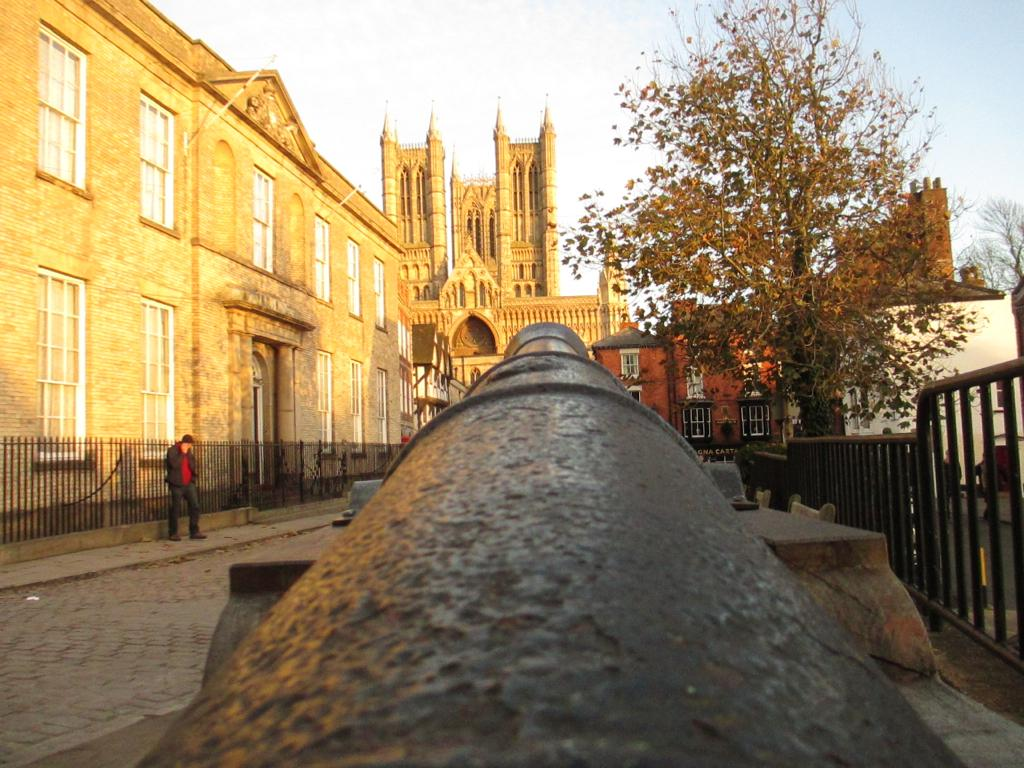What is the main object in the image? There is an object in the image, but the specific object is not mentioned in the facts. Can you describe the person in the image? There is a person in the image, but their appearance or actions are not mentioned in the facts. What can be seen under the person's feet in the image? The ground is visible in the image. What type of vegetation is present in the image? There are trees in the image. What type of barrier is present in the image? There is fencing in the image. What type of structures are visible in the image? There are buildings in the image. What is visible above the person in the image? The sky is visible in the image. What type of truck is parked next to the person in the image? There is no truck present in the image. What type of haircut does the person in the image have? The facts do not mention the person's haircut, so it cannot be determined from the image. 